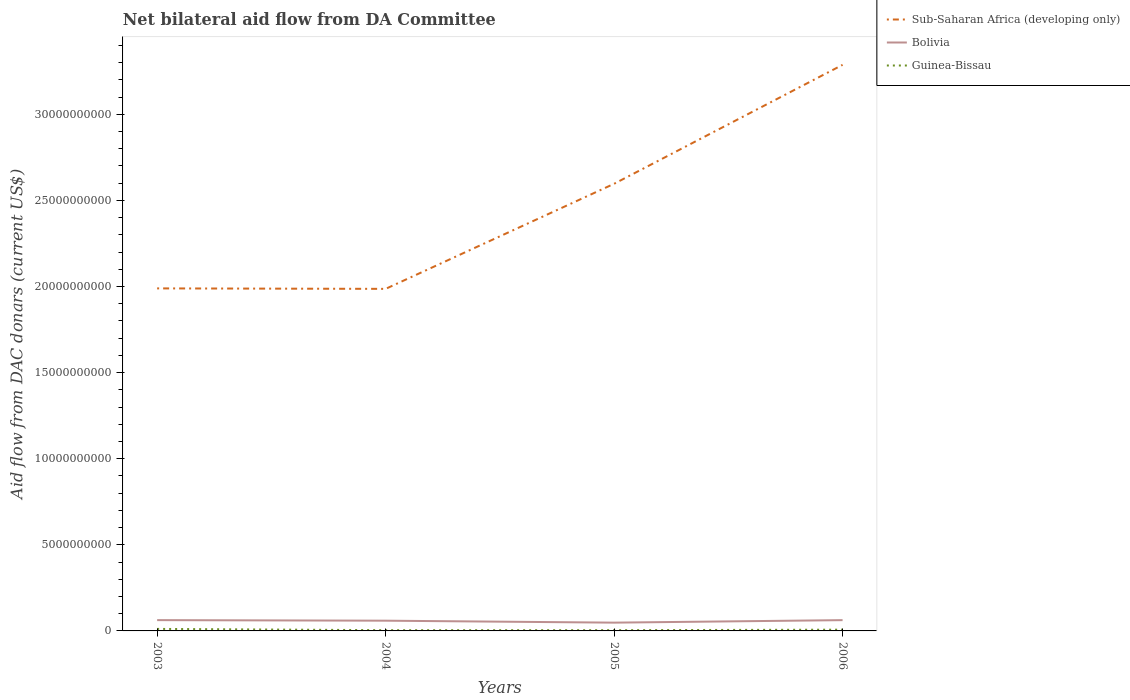How many different coloured lines are there?
Your response must be concise. 3. Does the line corresponding to Bolivia intersect with the line corresponding to Guinea-Bissau?
Your answer should be very brief. No. Is the number of lines equal to the number of legend labels?
Offer a terse response. Yes. Across all years, what is the maximum aid flow in in Guinea-Bissau?
Provide a short and direct response. 4.27e+07. In which year was the aid flow in in Guinea-Bissau maximum?
Your answer should be compact. 2004. What is the total aid flow in in Guinea-Bissau in the graph?
Provide a succinct answer. -3.90e+05. What is the difference between the highest and the second highest aid flow in in Sub-Saharan Africa (developing only)?
Ensure brevity in your answer.  1.30e+1. What is the difference between the highest and the lowest aid flow in in Guinea-Bissau?
Your answer should be compact. 2. Is the aid flow in in Bolivia strictly greater than the aid flow in in Sub-Saharan Africa (developing only) over the years?
Your answer should be very brief. Yes. How many lines are there?
Provide a succinct answer. 3. Are the values on the major ticks of Y-axis written in scientific E-notation?
Provide a succinct answer. No. Does the graph contain any zero values?
Provide a succinct answer. No. Does the graph contain grids?
Keep it short and to the point. No. Where does the legend appear in the graph?
Offer a terse response. Top right. How many legend labels are there?
Provide a short and direct response. 3. How are the legend labels stacked?
Provide a short and direct response. Vertical. What is the title of the graph?
Keep it short and to the point. Net bilateral aid flow from DA Committee. What is the label or title of the X-axis?
Provide a succinct answer. Years. What is the label or title of the Y-axis?
Keep it short and to the point. Aid flow from DAC donars (current US$). What is the Aid flow from DAC donars (current US$) of Sub-Saharan Africa (developing only) in 2003?
Your answer should be compact. 1.99e+1. What is the Aid flow from DAC donars (current US$) of Bolivia in 2003?
Make the answer very short. 6.27e+08. What is the Aid flow from DAC donars (current US$) of Guinea-Bissau in 2003?
Offer a terse response. 1.17e+08. What is the Aid flow from DAC donars (current US$) in Sub-Saharan Africa (developing only) in 2004?
Keep it short and to the point. 1.99e+1. What is the Aid flow from DAC donars (current US$) in Bolivia in 2004?
Give a very brief answer. 5.94e+08. What is the Aid flow from DAC donars (current US$) of Guinea-Bissau in 2004?
Offer a very short reply. 4.27e+07. What is the Aid flow from DAC donars (current US$) of Sub-Saharan Africa (developing only) in 2005?
Provide a short and direct response. 2.60e+1. What is the Aid flow from DAC donars (current US$) of Bolivia in 2005?
Provide a succinct answer. 4.81e+08. What is the Aid flow from DAC donars (current US$) in Guinea-Bissau in 2005?
Keep it short and to the point. 4.31e+07. What is the Aid flow from DAC donars (current US$) in Sub-Saharan Africa (developing only) in 2006?
Offer a terse response. 3.29e+1. What is the Aid flow from DAC donars (current US$) of Bolivia in 2006?
Give a very brief answer. 6.26e+08. What is the Aid flow from DAC donars (current US$) in Guinea-Bissau in 2006?
Offer a very short reply. 7.26e+07. Across all years, what is the maximum Aid flow from DAC donars (current US$) of Sub-Saharan Africa (developing only)?
Provide a succinct answer. 3.29e+1. Across all years, what is the maximum Aid flow from DAC donars (current US$) in Bolivia?
Make the answer very short. 6.27e+08. Across all years, what is the maximum Aid flow from DAC donars (current US$) of Guinea-Bissau?
Your answer should be very brief. 1.17e+08. Across all years, what is the minimum Aid flow from DAC donars (current US$) in Sub-Saharan Africa (developing only)?
Make the answer very short. 1.99e+1. Across all years, what is the minimum Aid flow from DAC donars (current US$) of Bolivia?
Provide a short and direct response. 4.81e+08. Across all years, what is the minimum Aid flow from DAC donars (current US$) of Guinea-Bissau?
Keep it short and to the point. 4.27e+07. What is the total Aid flow from DAC donars (current US$) in Sub-Saharan Africa (developing only) in the graph?
Keep it short and to the point. 9.86e+1. What is the total Aid flow from DAC donars (current US$) in Bolivia in the graph?
Ensure brevity in your answer.  2.33e+09. What is the total Aid flow from DAC donars (current US$) in Guinea-Bissau in the graph?
Provide a short and direct response. 2.76e+08. What is the difference between the Aid flow from DAC donars (current US$) of Sub-Saharan Africa (developing only) in 2003 and that in 2004?
Ensure brevity in your answer.  2.72e+07. What is the difference between the Aid flow from DAC donars (current US$) in Bolivia in 2003 and that in 2004?
Your response must be concise. 3.22e+07. What is the difference between the Aid flow from DAC donars (current US$) of Guinea-Bissau in 2003 and that in 2004?
Offer a very short reply. 7.46e+07. What is the difference between the Aid flow from DAC donars (current US$) in Sub-Saharan Africa (developing only) in 2003 and that in 2005?
Ensure brevity in your answer.  -6.07e+09. What is the difference between the Aid flow from DAC donars (current US$) of Bolivia in 2003 and that in 2005?
Your answer should be very brief. 1.45e+08. What is the difference between the Aid flow from DAC donars (current US$) in Guinea-Bissau in 2003 and that in 2005?
Offer a terse response. 7.42e+07. What is the difference between the Aid flow from DAC donars (current US$) in Sub-Saharan Africa (developing only) in 2003 and that in 2006?
Make the answer very short. -1.30e+1. What is the difference between the Aid flow from DAC donars (current US$) of Bolivia in 2003 and that in 2006?
Your answer should be compact. 2.40e+05. What is the difference between the Aid flow from DAC donars (current US$) in Guinea-Bissau in 2003 and that in 2006?
Your answer should be very brief. 4.47e+07. What is the difference between the Aid flow from DAC donars (current US$) in Sub-Saharan Africa (developing only) in 2004 and that in 2005?
Your answer should be very brief. -6.10e+09. What is the difference between the Aid flow from DAC donars (current US$) in Bolivia in 2004 and that in 2005?
Make the answer very short. 1.13e+08. What is the difference between the Aid flow from DAC donars (current US$) of Guinea-Bissau in 2004 and that in 2005?
Offer a terse response. -3.90e+05. What is the difference between the Aid flow from DAC donars (current US$) in Sub-Saharan Africa (developing only) in 2004 and that in 2006?
Provide a short and direct response. -1.30e+1. What is the difference between the Aid flow from DAC donars (current US$) of Bolivia in 2004 and that in 2006?
Offer a very short reply. -3.19e+07. What is the difference between the Aid flow from DAC donars (current US$) in Guinea-Bissau in 2004 and that in 2006?
Make the answer very short. -2.99e+07. What is the difference between the Aid flow from DAC donars (current US$) of Sub-Saharan Africa (developing only) in 2005 and that in 2006?
Offer a very short reply. -6.91e+09. What is the difference between the Aid flow from DAC donars (current US$) of Bolivia in 2005 and that in 2006?
Keep it short and to the point. -1.45e+08. What is the difference between the Aid flow from DAC donars (current US$) of Guinea-Bissau in 2005 and that in 2006?
Your answer should be very brief. -2.96e+07. What is the difference between the Aid flow from DAC donars (current US$) in Sub-Saharan Africa (developing only) in 2003 and the Aid flow from DAC donars (current US$) in Bolivia in 2004?
Offer a very short reply. 1.93e+1. What is the difference between the Aid flow from DAC donars (current US$) of Sub-Saharan Africa (developing only) in 2003 and the Aid flow from DAC donars (current US$) of Guinea-Bissau in 2004?
Offer a terse response. 1.98e+1. What is the difference between the Aid flow from DAC donars (current US$) in Bolivia in 2003 and the Aid flow from DAC donars (current US$) in Guinea-Bissau in 2004?
Provide a succinct answer. 5.84e+08. What is the difference between the Aid flow from DAC donars (current US$) in Sub-Saharan Africa (developing only) in 2003 and the Aid flow from DAC donars (current US$) in Bolivia in 2005?
Ensure brevity in your answer.  1.94e+1. What is the difference between the Aid flow from DAC donars (current US$) of Sub-Saharan Africa (developing only) in 2003 and the Aid flow from DAC donars (current US$) of Guinea-Bissau in 2005?
Give a very brief answer. 1.98e+1. What is the difference between the Aid flow from DAC donars (current US$) of Bolivia in 2003 and the Aid flow from DAC donars (current US$) of Guinea-Bissau in 2005?
Give a very brief answer. 5.83e+08. What is the difference between the Aid flow from DAC donars (current US$) in Sub-Saharan Africa (developing only) in 2003 and the Aid flow from DAC donars (current US$) in Bolivia in 2006?
Ensure brevity in your answer.  1.93e+1. What is the difference between the Aid flow from DAC donars (current US$) in Sub-Saharan Africa (developing only) in 2003 and the Aid flow from DAC donars (current US$) in Guinea-Bissau in 2006?
Ensure brevity in your answer.  1.98e+1. What is the difference between the Aid flow from DAC donars (current US$) of Bolivia in 2003 and the Aid flow from DAC donars (current US$) of Guinea-Bissau in 2006?
Your response must be concise. 5.54e+08. What is the difference between the Aid flow from DAC donars (current US$) in Sub-Saharan Africa (developing only) in 2004 and the Aid flow from DAC donars (current US$) in Bolivia in 2005?
Ensure brevity in your answer.  1.94e+1. What is the difference between the Aid flow from DAC donars (current US$) in Sub-Saharan Africa (developing only) in 2004 and the Aid flow from DAC donars (current US$) in Guinea-Bissau in 2005?
Your answer should be very brief. 1.98e+1. What is the difference between the Aid flow from DAC donars (current US$) in Bolivia in 2004 and the Aid flow from DAC donars (current US$) in Guinea-Bissau in 2005?
Your response must be concise. 5.51e+08. What is the difference between the Aid flow from DAC donars (current US$) of Sub-Saharan Africa (developing only) in 2004 and the Aid flow from DAC donars (current US$) of Bolivia in 2006?
Give a very brief answer. 1.92e+1. What is the difference between the Aid flow from DAC donars (current US$) of Sub-Saharan Africa (developing only) in 2004 and the Aid flow from DAC donars (current US$) of Guinea-Bissau in 2006?
Keep it short and to the point. 1.98e+1. What is the difference between the Aid flow from DAC donars (current US$) of Bolivia in 2004 and the Aid flow from DAC donars (current US$) of Guinea-Bissau in 2006?
Your response must be concise. 5.22e+08. What is the difference between the Aid flow from DAC donars (current US$) of Sub-Saharan Africa (developing only) in 2005 and the Aid flow from DAC donars (current US$) of Bolivia in 2006?
Provide a short and direct response. 2.53e+1. What is the difference between the Aid flow from DAC donars (current US$) in Sub-Saharan Africa (developing only) in 2005 and the Aid flow from DAC donars (current US$) in Guinea-Bissau in 2006?
Your answer should be very brief. 2.59e+1. What is the difference between the Aid flow from DAC donars (current US$) in Bolivia in 2005 and the Aid flow from DAC donars (current US$) in Guinea-Bissau in 2006?
Offer a very short reply. 4.08e+08. What is the average Aid flow from DAC donars (current US$) of Sub-Saharan Africa (developing only) per year?
Offer a terse response. 2.46e+1. What is the average Aid flow from DAC donars (current US$) in Bolivia per year?
Provide a succinct answer. 5.82e+08. What is the average Aid flow from DAC donars (current US$) in Guinea-Bissau per year?
Give a very brief answer. 6.90e+07. In the year 2003, what is the difference between the Aid flow from DAC donars (current US$) of Sub-Saharan Africa (developing only) and Aid flow from DAC donars (current US$) of Bolivia?
Give a very brief answer. 1.93e+1. In the year 2003, what is the difference between the Aid flow from DAC donars (current US$) of Sub-Saharan Africa (developing only) and Aid flow from DAC donars (current US$) of Guinea-Bissau?
Make the answer very short. 1.98e+1. In the year 2003, what is the difference between the Aid flow from DAC donars (current US$) of Bolivia and Aid flow from DAC donars (current US$) of Guinea-Bissau?
Provide a short and direct response. 5.09e+08. In the year 2004, what is the difference between the Aid flow from DAC donars (current US$) of Sub-Saharan Africa (developing only) and Aid flow from DAC donars (current US$) of Bolivia?
Your answer should be compact. 1.93e+1. In the year 2004, what is the difference between the Aid flow from DAC donars (current US$) in Sub-Saharan Africa (developing only) and Aid flow from DAC donars (current US$) in Guinea-Bissau?
Provide a short and direct response. 1.98e+1. In the year 2004, what is the difference between the Aid flow from DAC donars (current US$) in Bolivia and Aid flow from DAC donars (current US$) in Guinea-Bissau?
Your answer should be compact. 5.52e+08. In the year 2005, what is the difference between the Aid flow from DAC donars (current US$) in Sub-Saharan Africa (developing only) and Aid flow from DAC donars (current US$) in Bolivia?
Make the answer very short. 2.55e+1. In the year 2005, what is the difference between the Aid flow from DAC donars (current US$) in Sub-Saharan Africa (developing only) and Aid flow from DAC donars (current US$) in Guinea-Bissau?
Your response must be concise. 2.59e+1. In the year 2005, what is the difference between the Aid flow from DAC donars (current US$) of Bolivia and Aid flow from DAC donars (current US$) of Guinea-Bissau?
Provide a succinct answer. 4.38e+08. In the year 2006, what is the difference between the Aid flow from DAC donars (current US$) in Sub-Saharan Africa (developing only) and Aid flow from DAC donars (current US$) in Bolivia?
Your answer should be very brief. 3.22e+1. In the year 2006, what is the difference between the Aid flow from DAC donars (current US$) in Sub-Saharan Africa (developing only) and Aid flow from DAC donars (current US$) in Guinea-Bissau?
Keep it short and to the point. 3.28e+1. In the year 2006, what is the difference between the Aid flow from DAC donars (current US$) of Bolivia and Aid flow from DAC donars (current US$) of Guinea-Bissau?
Ensure brevity in your answer.  5.54e+08. What is the ratio of the Aid flow from DAC donars (current US$) of Sub-Saharan Africa (developing only) in 2003 to that in 2004?
Ensure brevity in your answer.  1. What is the ratio of the Aid flow from DAC donars (current US$) in Bolivia in 2003 to that in 2004?
Give a very brief answer. 1.05. What is the ratio of the Aid flow from DAC donars (current US$) in Guinea-Bissau in 2003 to that in 2004?
Ensure brevity in your answer.  2.75. What is the ratio of the Aid flow from DAC donars (current US$) of Sub-Saharan Africa (developing only) in 2003 to that in 2005?
Your response must be concise. 0.77. What is the ratio of the Aid flow from DAC donars (current US$) in Bolivia in 2003 to that in 2005?
Keep it short and to the point. 1.3. What is the ratio of the Aid flow from DAC donars (current US$) in Guinea-Bissau in 2003 to that in 2005?
Your response must be concise. 2.72. What is the ratio of the Aid flow from DAC donars (current US$) in Sub-Saharan Africa (developing only) in 2003 to that in 2006?
Give a very brief answer. 0.61. What is the ratio of the Aid flow from DAC donars (current US$) in Bolivia in 2003 to that in 2006?
Provide a short and direct response. 1. What is the ratio of the Aid flow from DAC donars (current US$) in Guinea-Bissau in 2003 to that in 2006?
Your answer should be compact. 1.62. What is the ratio of the Aid flow from DAC donars (current US$) of Sub-Saharan Africa (developing only) in 2004 to that in 2005?
Your response must be concise. 0.77. What is the ratio of the Aid flow from DAC donars (current US$) in Bolivia in 2004 to that in 2005?
Provide a succinct answer. 1.24. What is the ratio of the Aid flow from DAC donars (current US$) in Guinea-Bissau in 2004 to that in 2005?
Make the answer very short. 0.99. What is the ratio of the Aid flow from DAC donars (current US$) of Sub-Saharan Africa (developing only) in 2004 to that in 2006?
Offer a very short reply. 0.6. What is the ratio of the Aid flow from DAC donars (current US$) of Bolivia in 2004 to that in 2006?
Keep it short and to the point. 0.95. What is the ratio of the Aid flow from DAC donars (current US$) in Guinea-Bissau in 2004 to that in 2006?
Provide a short and direct response. 0.59. What is the ratio of the Aid flow from DAC donars (current US$) in Sub-Saharan Africa (developing only) in 2005 to that in 2006?
Keep it short and to the point. 0.79. What is the ratio of the Aid flow from DAC donars (current US$) in Bolivia in 2005 to that in 2006?
Your response must be concise. 0.77. What is the ratio of the Aid flow from DAC donars (current US$) of Guinea-Bissau in 2005 to that in 2006?
Ensure brevity in your answer.  0.59. What is the difference between the highest and the second highest Aid flow from DAC donars (current US$) in Sub-Saharan Africa (developing only)?
Offer a terse response. 6.91e+09. What is the difference between the highest and the second highest Aid flow from DAC donars (current US$) in Bolivia?
Your answer should be compact. 2.40e+05. What is the difference between the highest and the second highest Aid flow from DAC donars (current US$) of Guinea-Bissau?
Give a very brief answer. 4.47e+07. What is the difference between the highest and the lowest Aid flow from DAC donars (current US$) of Sub-Saharan Africa (developing only)?
Offer a terse response. 1.30e+1. What is the difference between the highest and the lowest Aid flow from DAC donars (current US$) of Bolivia?
Provide a short and direct response. 1.45e+08. What is the difference between the highest and the lowest Aid flow from DAC donars (current US$) of Guinea-Bissau?
Your response must be concise. 7.46e+07. 